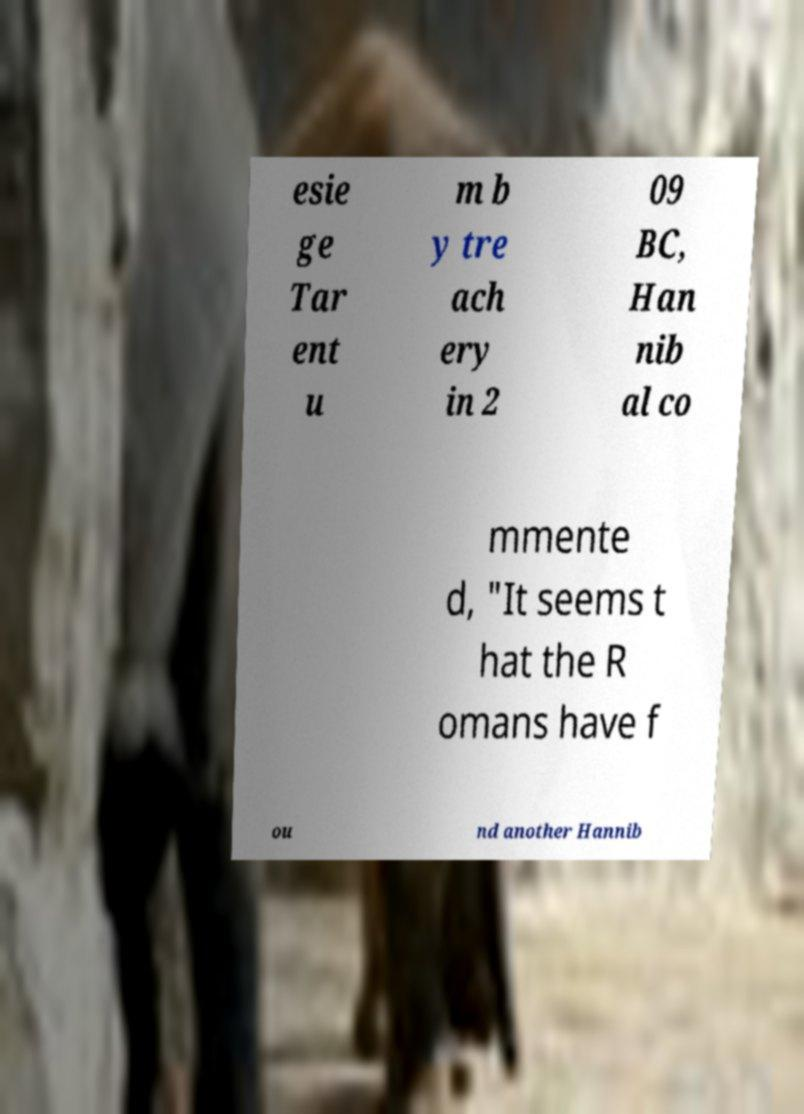Can you read and provide the text displayed in the image?This photo seems to have some interesting text. Can you extract and type it out for me? esie ge Tar ent u m b y tre ach ery in 2 09 BC, Han nib al co mmente d, "It seems t hat the R omans have f ou nd another Hannib 